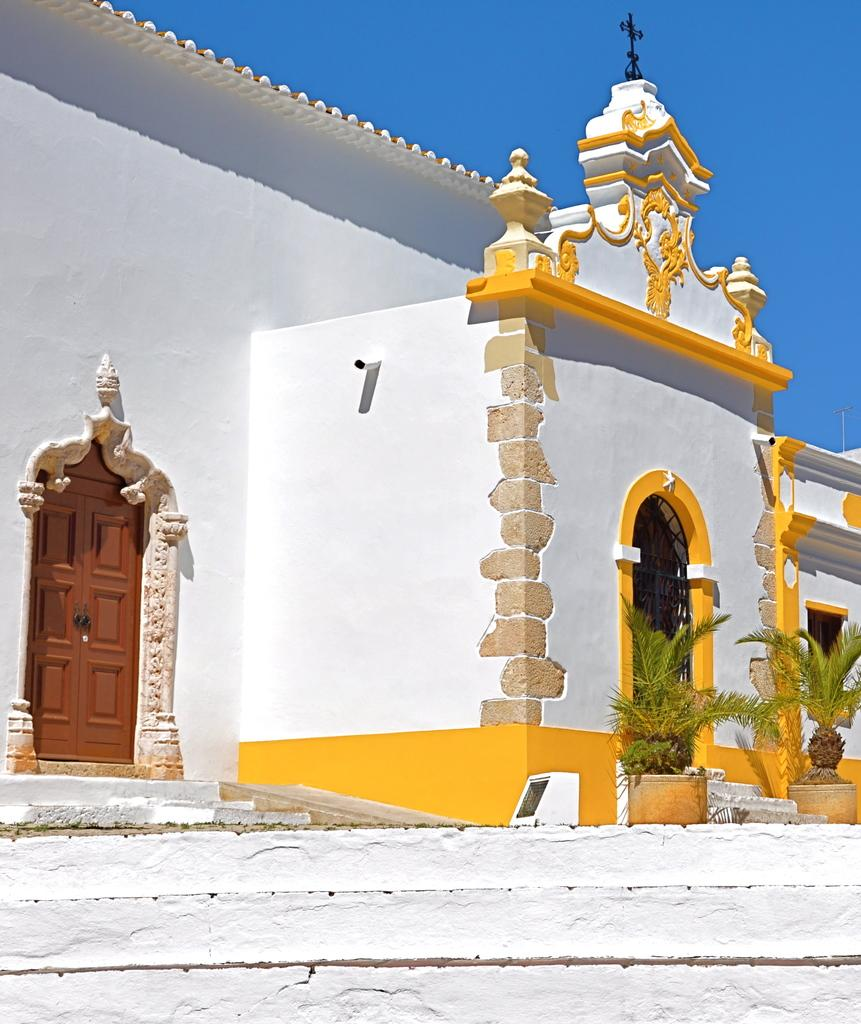What type of structure is present in the image? There is a building in the image. What feature of the building is mentioned in the facts? The building has doors. What can be seen on the right side of the image? There are plants on the right side of the image. What is visible at the top of the image? The sky is visible at the top of the image. What type of behavior can be observed in the building's hands in the image? There is no mention of hands or behavior in the building in the image; it only has doors and is surrounded by plants and sky. 